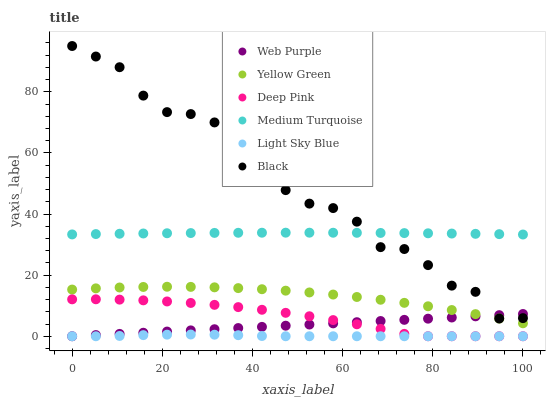Does Light Sky Blue have the minimum area under the curve?
Answer yes or no. Yes. Does Black have the maximum area under the curve?
Answer yes or no. Yes. Does Yellow Green have the minimum area under the curve?
Answer yes or no. No. Does Yellow Green have the maximum area under the curve?
Answer yes or no. No. Is Web Purple the smoothest?
Answer yes or no. Yes. Is Black the roughest?
Answer yes or no. Yes. Is Yellow Green the smoothest?
Answer yes or no. No. Is Yellow Green the roughest?
Answer yes or no. No. Does Deep Pink have the lowest value?
Answer yes or no. Yes. Does Yellow Green have the lowest value?
Answer yes or no. No. Does Black have the highest value?
Answer yes or no. Yes. Does Yellow Green have the highest value?
Answer yes or no. No. Is Deep Pink less than Yellow Green?
Answer yes or no. Yes. Is Medium Turquoise greater than Deep Pink?
Answer yes or no. Yes. Does Deep Pink intersect Web Purple?
Answer yes or no. Yes. Is Deep Pink less than Web Purple?
Answer yes or no. No. Is Deep Pink greater than Web Purple?
Answer yes or no. No. Does Deep Pink intersect Yellow Green?
Answer yes or no. No. 